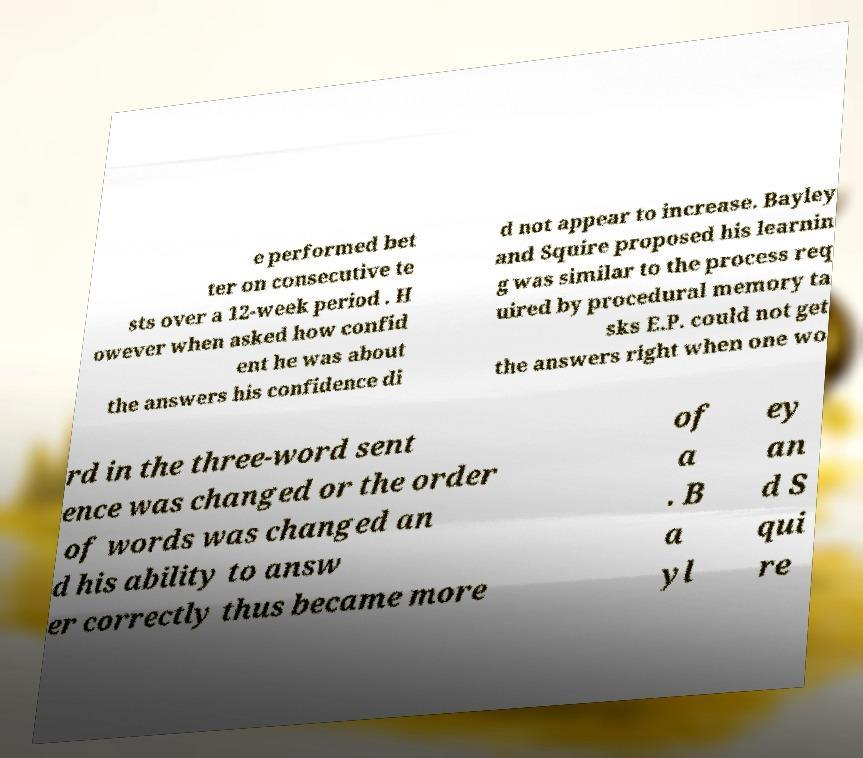There's text embedded in this image that I need extracted. Can you transcribe it verbatim? e performed bet ter on consecutive te sts over a 12-week period . H owever when asked how confid ent he was about the answers his confidence di d not appear to increase. Bayley and Squire proposed his learnin g was similar to the process req uired by procedural memory ta sks E.P. could not get the answers right when one wo rd in the three-word sent ence was changed or the order of words was changed an d his ability to answ er correctly thus became more of a . B a yl ey an d S qui re 